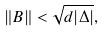<formula> <loc_0><loc_0><loc_500><loc_500>\| B \| < \sqrt { d | \Delta | } ,</formula> 